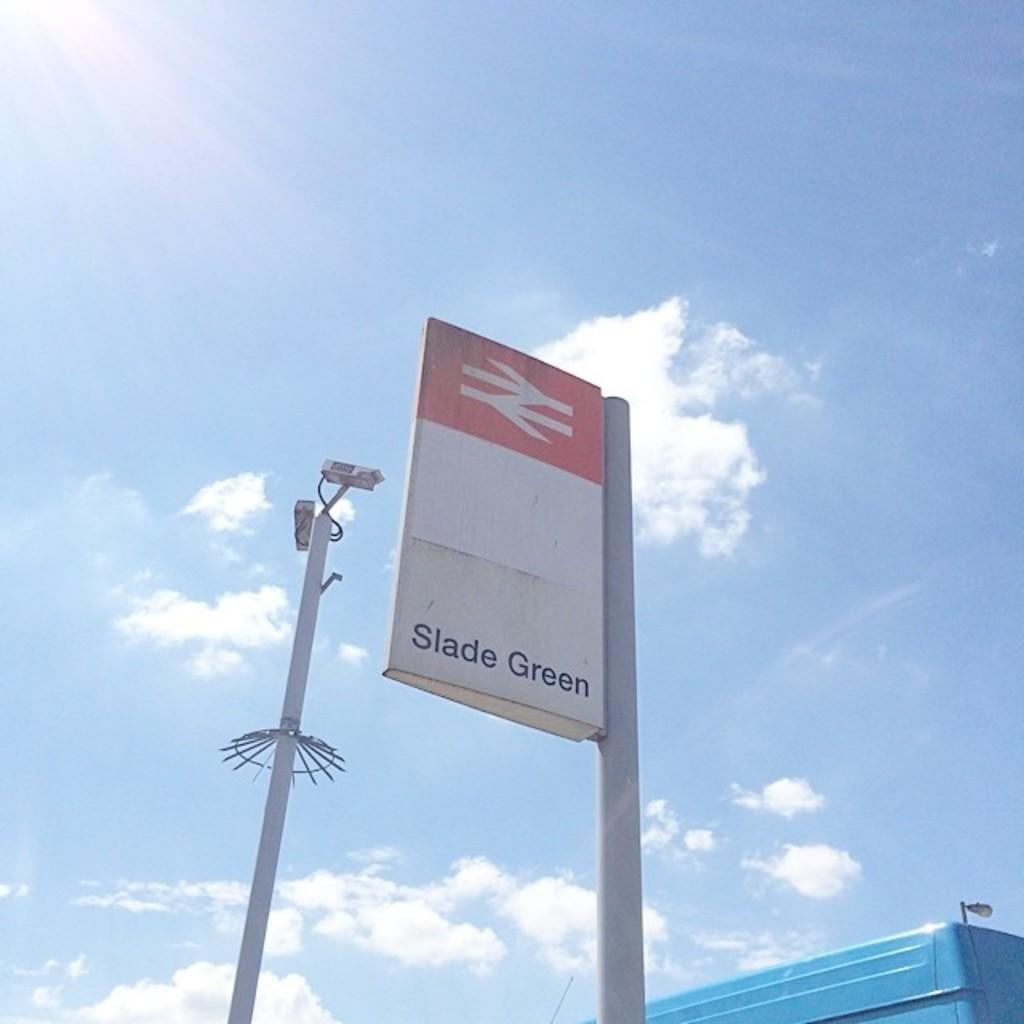<image>
Provide a brief description of the given image. A red and white outdoor sign reading Slade Green. 